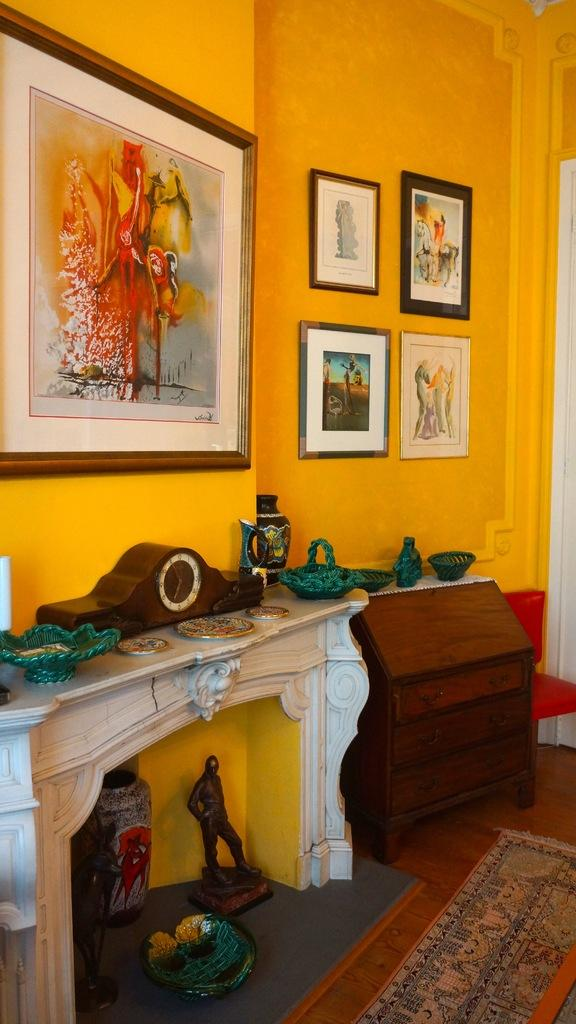What can be seen hanging on the wall in the image? There are photo frames on the wall. What time-telling device is present in the image? There is a clock in the image. What type of tableware is visible in the image? There are plates in the image. What type of container is present in the image? There is a jar in the image. What type of decorative object is present in the image? There is a small statue in the image. What type of floor covering is present in the image? There is a mat on the floor. How many cars are parked on the mat in the image? There are no cars present in the image; the mat is a floor covering. What type of emotion does the small statue express in the image? The small statue does not express any emotion, as it is an inanimate object. 